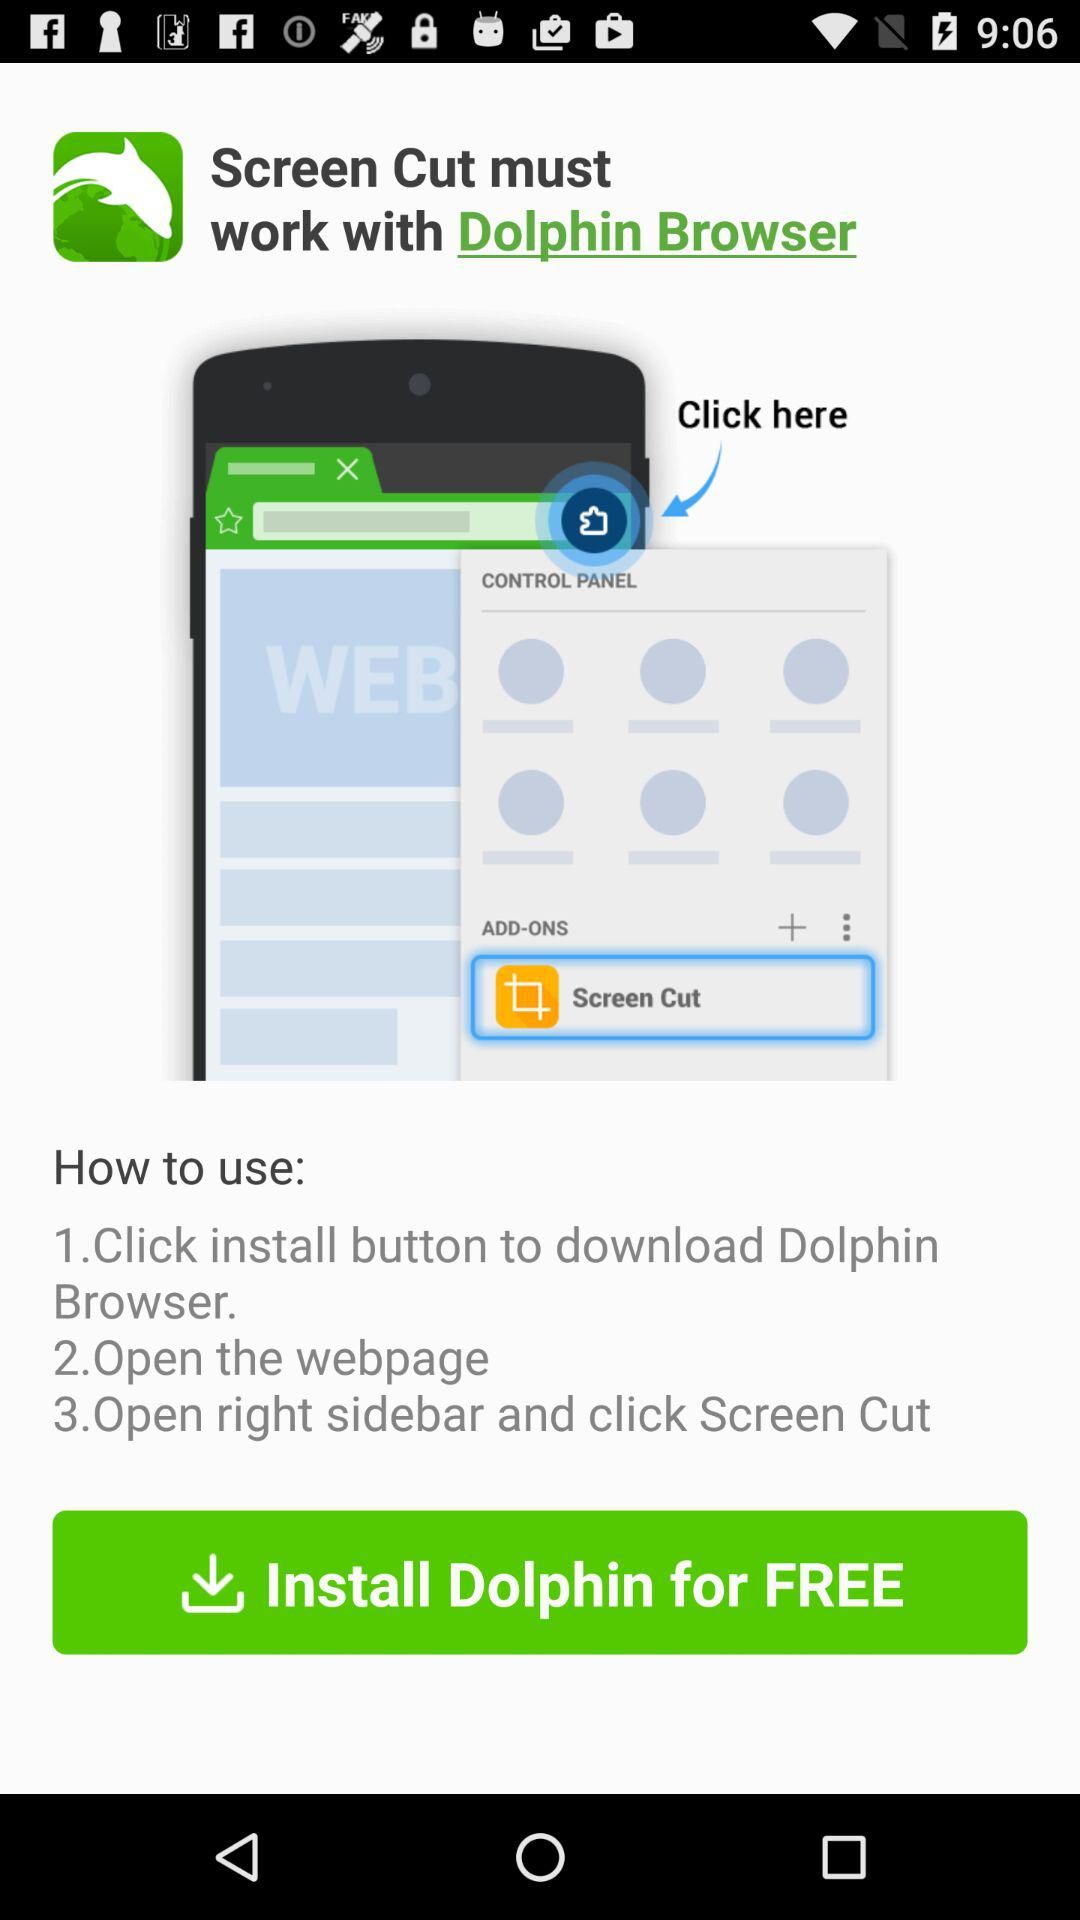What option is present in ADD - ONS? The option is "Screen Cut". 